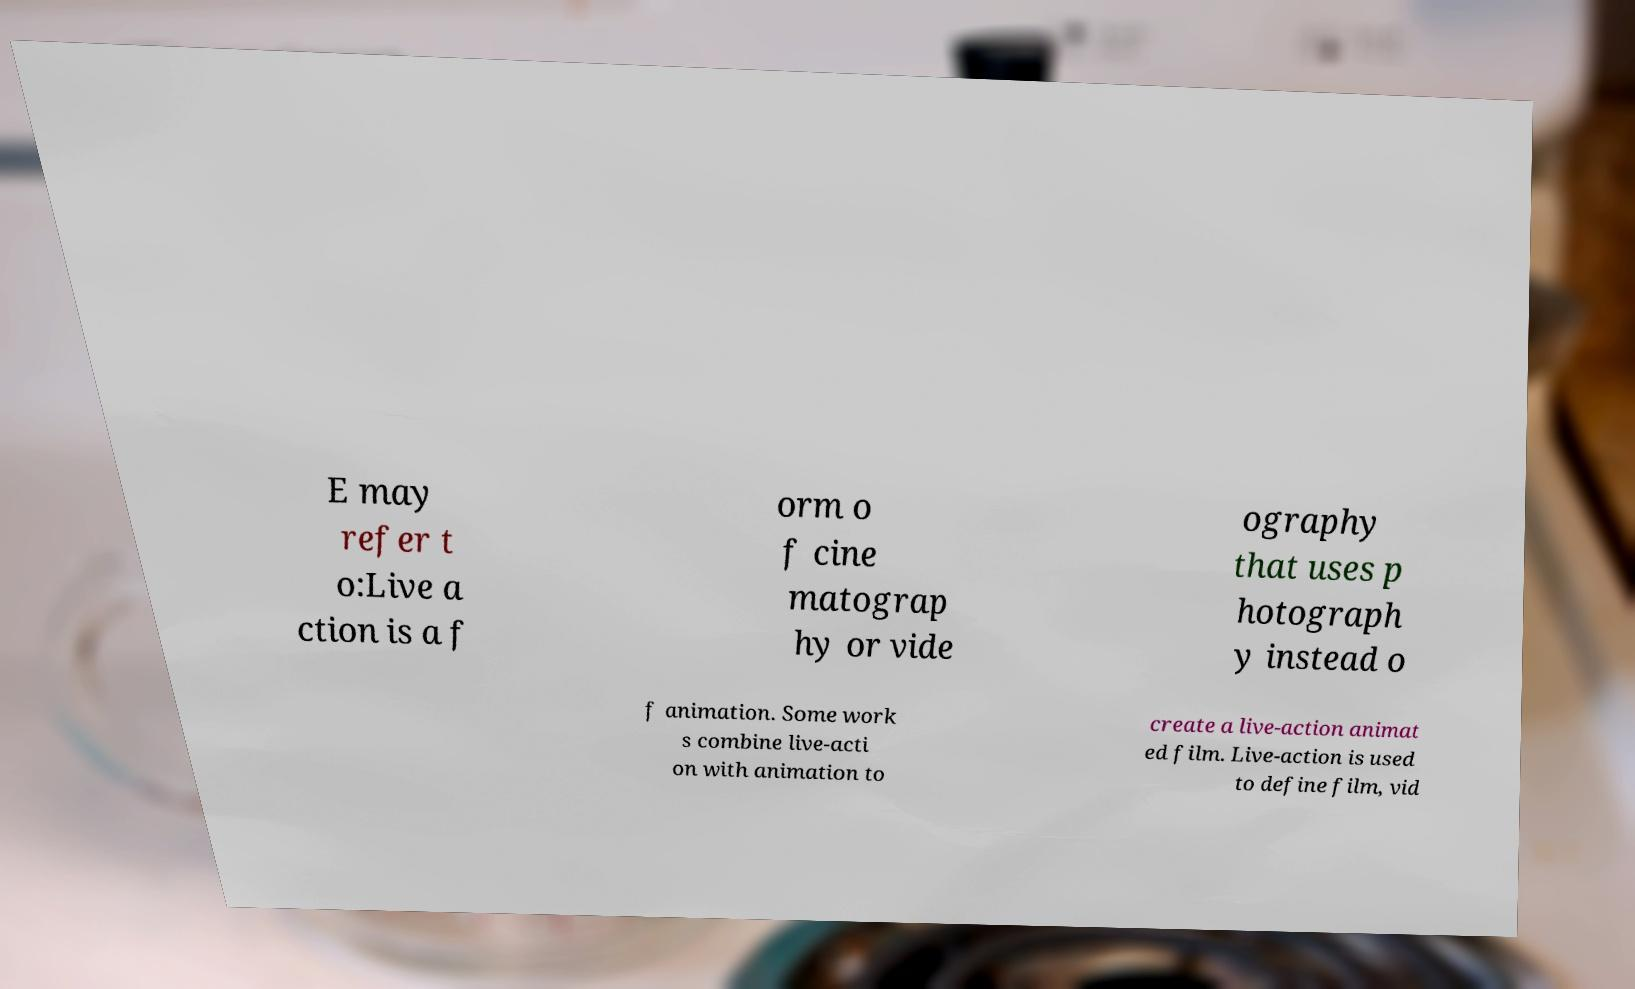There's text embedded in this image that I need extracted. Can you transcribe it verbatim? E may refer t o:Live a ction is a f orm o f cine matograp hy or vide ography that uses p hotograph y instead o f animation. Some work s combine live-acti on with animation to create a live-action animat ed film. Live-action is used to define film, vid 